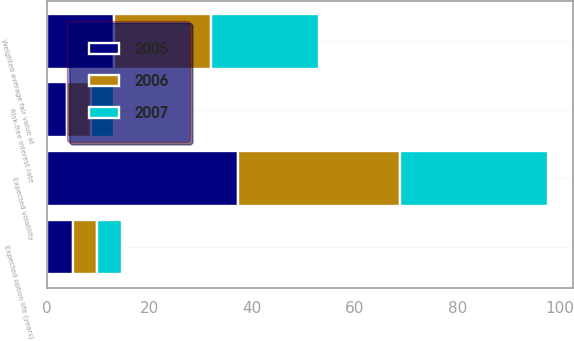Convert chart. <chart><loc_0><loc_0><loc_500><loc_500><stacked_bar_chart><ecel><fcel>Weighted average fair value at<fcel>Expected option life (years)<fcel>Expected volatility<fcel>Risk-free interest rate<nl><fcel>2007<fcel>21.07<fcel>4.8<fcel>28.9<fcel>4.5<nl><fcel>2006<fcel>19.1<fcel>4.8<fcel>31.6<fcel>4.6<nl><fcel>2005<fcel>12.93<fcel>5<fcel>37.2<fcel>3.9<nl></chart> 